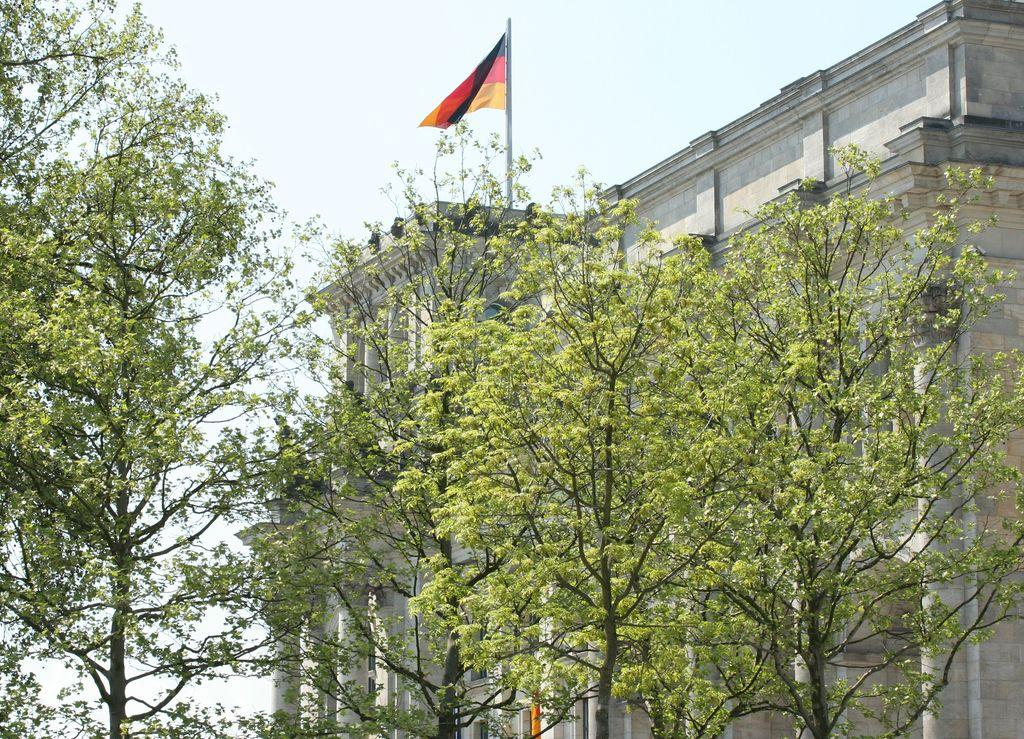What is located in the center of the image? There are trees in the center of the image. What can be seen in the background of the image? There is a building in the background of the image. What is on top of the building? There is a flag on top of the building. How would you describe the sky in the image? The sky is cloudy in the image. What type of drum can be heard playing in the image? There is no drum present or audible in the image. 